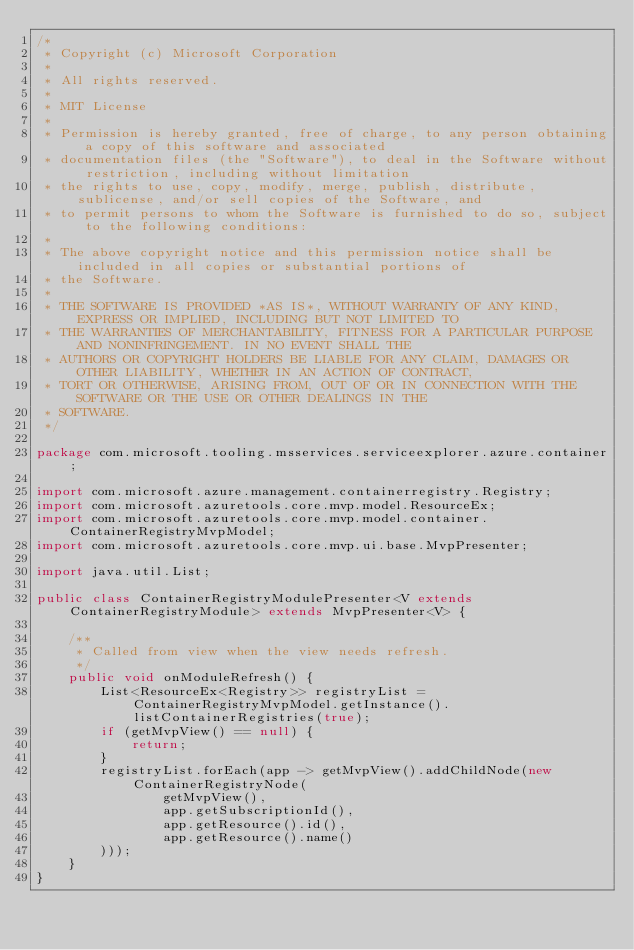Convert code to text. <code><loc_0><loc_0><loc_500><loc_500><_Java_>/*
 * Copyright (c) Microsoft Corporation
 *
 * All rights reserved.
 *
 * MIT License
 *
 * Permission is hereby granted, free of charge, to any person obtaining a copy of this software and associated
 * documentation files (the "Software"), to deal in the Software without restriction, including without limitation
 * the rights to use, copy, modify, merge, publish, distribute, sublicense, and/or sell copies of the Software, and
 * to permit persons to whom the Software is furnished to do so, subject to the following conditions:
 *
 * The above copyright notice and this permission notice shall be included in all copies or substantial portions of
 * the Software.
 *
 * THE SOFTWARE IS PROVIDED *AS IS*, WITHOUT WARRANTY OF ANY KIND, EXPRESS OR IMPLIED, INCLUDING BUT NOT LIMITED TO
 * THE WARRANTIES OF MERCHANTABILITY, FITNESS FOR A PARTICULAR PURPOSE AND NONINFRINGEMENT. IN NO EVENT SHALL THE
 * AUTHORS OR COPYRIGHT HOLDERS BE LIABLE FOR ANY CLAIM, DAMAGES OR OTHER LIABILITY, WHETHER IN AN ACTION OF CONTRACT,
 * TORT OR OTHERWISE, ARISING FROM, OUT OF OR IN CONNECTION WITH THE SOFTWARE OR THE USE OR OTHER DEALINGS IN THE
 * SOFTWARE.
 */

package com.microsoft.tooling.msservices.serviceexplorer.azure.container;

import com.microsoft.azure.management.containerregistry.Registry;
import com.microsoft.azuretools.core.mvp.model.ResourceEx;
import com.microsoft.azuretools.core.mvp.model.container.ContainerRegistryMvpModel;
import com.microsoft.azuretools.core.mvp.ui.base.MvpPresenter;

import java.util.List;

public class ContainerRegistryModulePresenter<V extends ContainerRegistryModule> extends MvpPresenter<V> {

    /**
     * Called from view when the view needs refresh.
     */
    public void onModuleRefresh() {
        List<ResourceEx<Registry>> registryList = ContainerRegistryMvpModel.getInstance().listContainerRegistries(true);
        if (getMvpView() == null) {
            return;
        }
        registryList.forEach(app -> getMvpView().addChildNode(new ContainerRegistryNode(
                getMvpView(),
                app.getSubscriptionId(),
                app.getResource().id(),
                app.getResource().name()
        )));
    }
}
</code> 